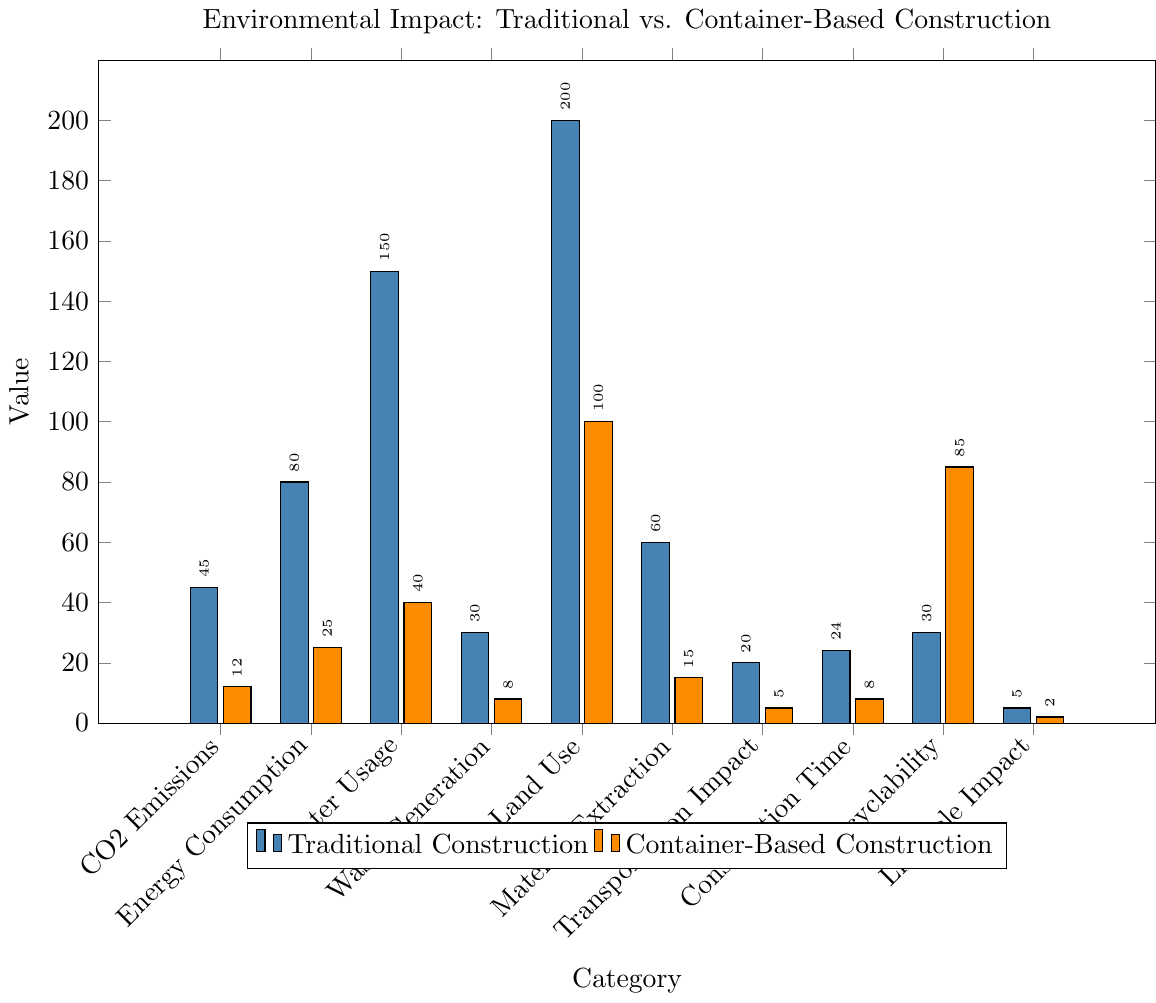What's the largest difference in CO2 Emissions between the two construction methods? The bar for CO2 Emissions shows Traditional Construction at 45 tons and Container-Based Construction at 12 tons. Subtracting 12 from 45 gives the difference.
Answer: 33 tons Which construction method uses less water, and by how much? Traditional Construction uses 150,000 liters of water, and Container-Based Construction uses 40,000 liters. Subtracting 40 from 150 gives the difference.
Answer: Container-Based Construction by 110,000 liters In terms of Energy Consumption, calculate the percentage reduction when using Container-Based Construction compared to Traditional Construction. Traditional Construction uses 80 MWh, and Container-Based Construction uses 25 MWh. The reduction is (80 - 25) / 80 * 100.
Answer: 68.75% Which construction method has a higher recyclability percentage, and what is the percentage point difference? Traditional Construction has a recyclability percentage of 30%, while Container-Based has 85%. Subtracting 30 from 85 gives the difference.
Answer: Container-Based Construction by 55 percentage points How much lower is the Land Use for Container-Based Construction compared to Traditional Construction? Traditional Construction uses 200 sq meters of land, and Container-Based Construction uses 100 sq meters. Subtracting 100 from 200 gives the difference.
Answer: 100 sq meters What's the sum of Waste Generation for both construction methods? Traditional Construction generates 30 tons of waste, and Container-Based Construction generates 8 tons. Adding them together gives the total.
Answer: 38 tons Which construction method has a lower Lifecycle Impact in CO2 tons per year, and by how much? Traditional Construction has a Lifecycle Impact of 5 CO2 tons per year, and Container-Based Construction has 2 CO2 tons per year. Subtracting 2 from 5 gives the difference.
Answer: Container-Based Construction by 3 CO2 tons per year What is the ratio of Transportation Impact (CO2 tons) between Traditional and Container-Based Construction? Traditional Construction has a Transportation Impact of 20 CO2 tons, and Container-Based Construction has 5 CO2 tons. Dividing 20 by 5 gives the ratio.
Answer: 4:1 How much faster is Container-Based Construction in terms of weeks? Traditional Construction takes 24 weeks, and Container-Based Construction takes 8 weeks. Subtracting 8 from 24 gives the difference.
Answer: 16 weeks What is the total Material Extraction for both construction methods? Traditional Construction extracts 60 tons of material, and Container-Based Construction extracts 15 tons. Adding them together gives the total.
Answer: 75 tons 